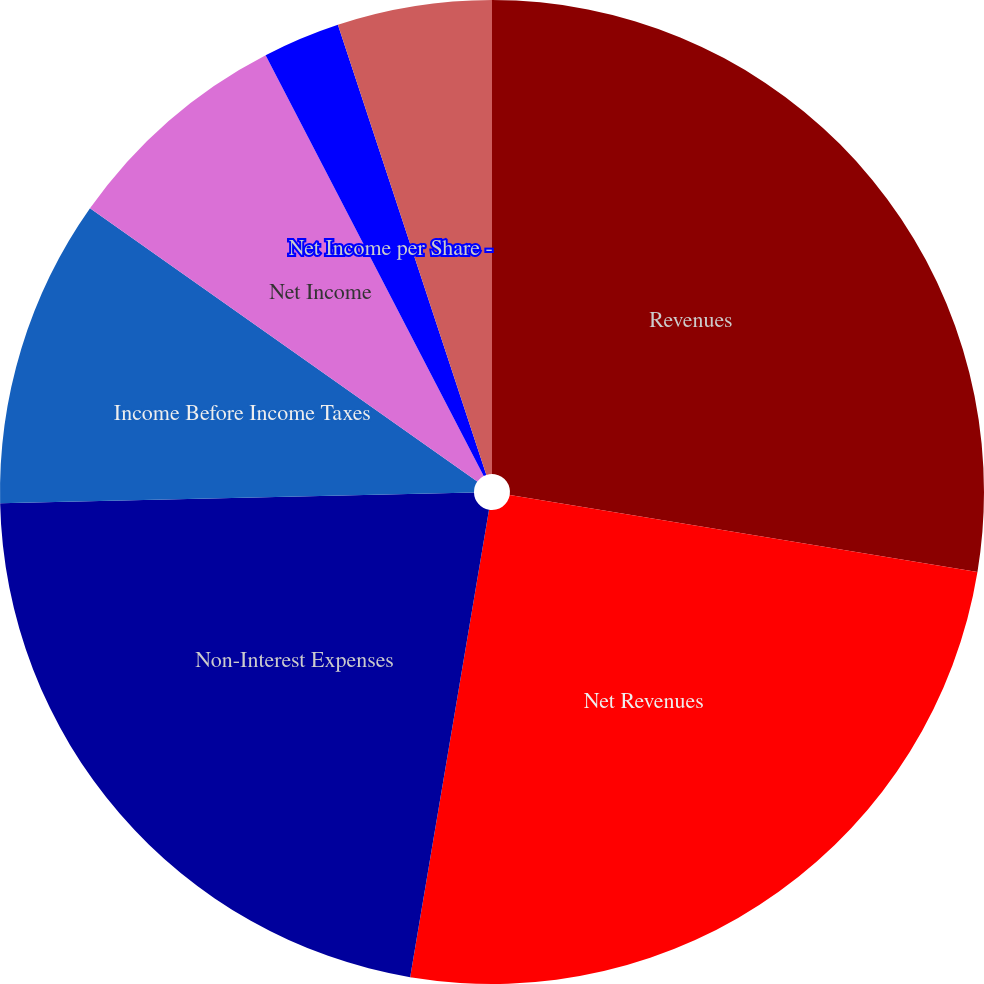Convert chart to OTSL. <chart><loc_0><loc_0><loc_500><loc_500><pie_chart><fcel>Revenues<fcel>Net Revenues<fcel>Non-Interest Expenses<fcel>Income Before Income Taxes<fcel>Net Income<fcel>Net Income per Share -<fcel>Net Income per Share - Diluted<fcel>Dividends Declared per Share<nl><fcel>27.6%<fcel>25.06%<fcel>21.98%<fcel>10.14%<fcel>7.61%<fcel>2.54%<fcel>5.07%<fcel>0.0%<nl></chart> 